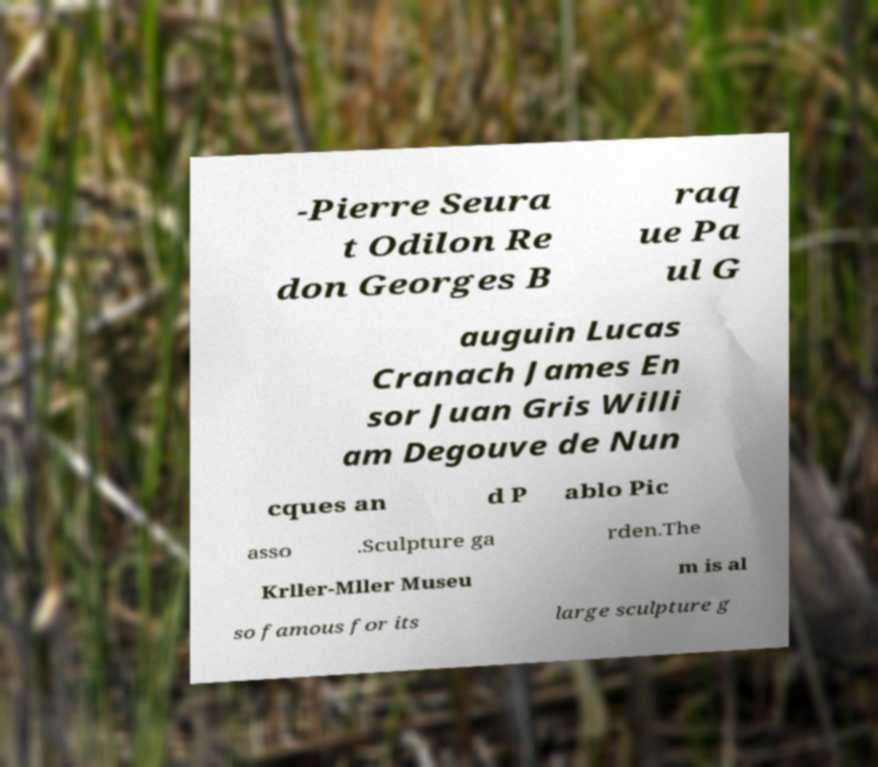Can you read and provide the text displayed in the image?This photo seems to have some interesting text. Can you extract and type it out for me? -Pierre Seura t Odilon Re don Georges B raq ue Pa ul G auguin Lucas Cranach James En sor Juan Gris Willi am Degouve de Nun cques an d P ablo Pic asso .Sculpture ga rden.The Krller-Mller Museu m is al so famous for its large sculpture g 